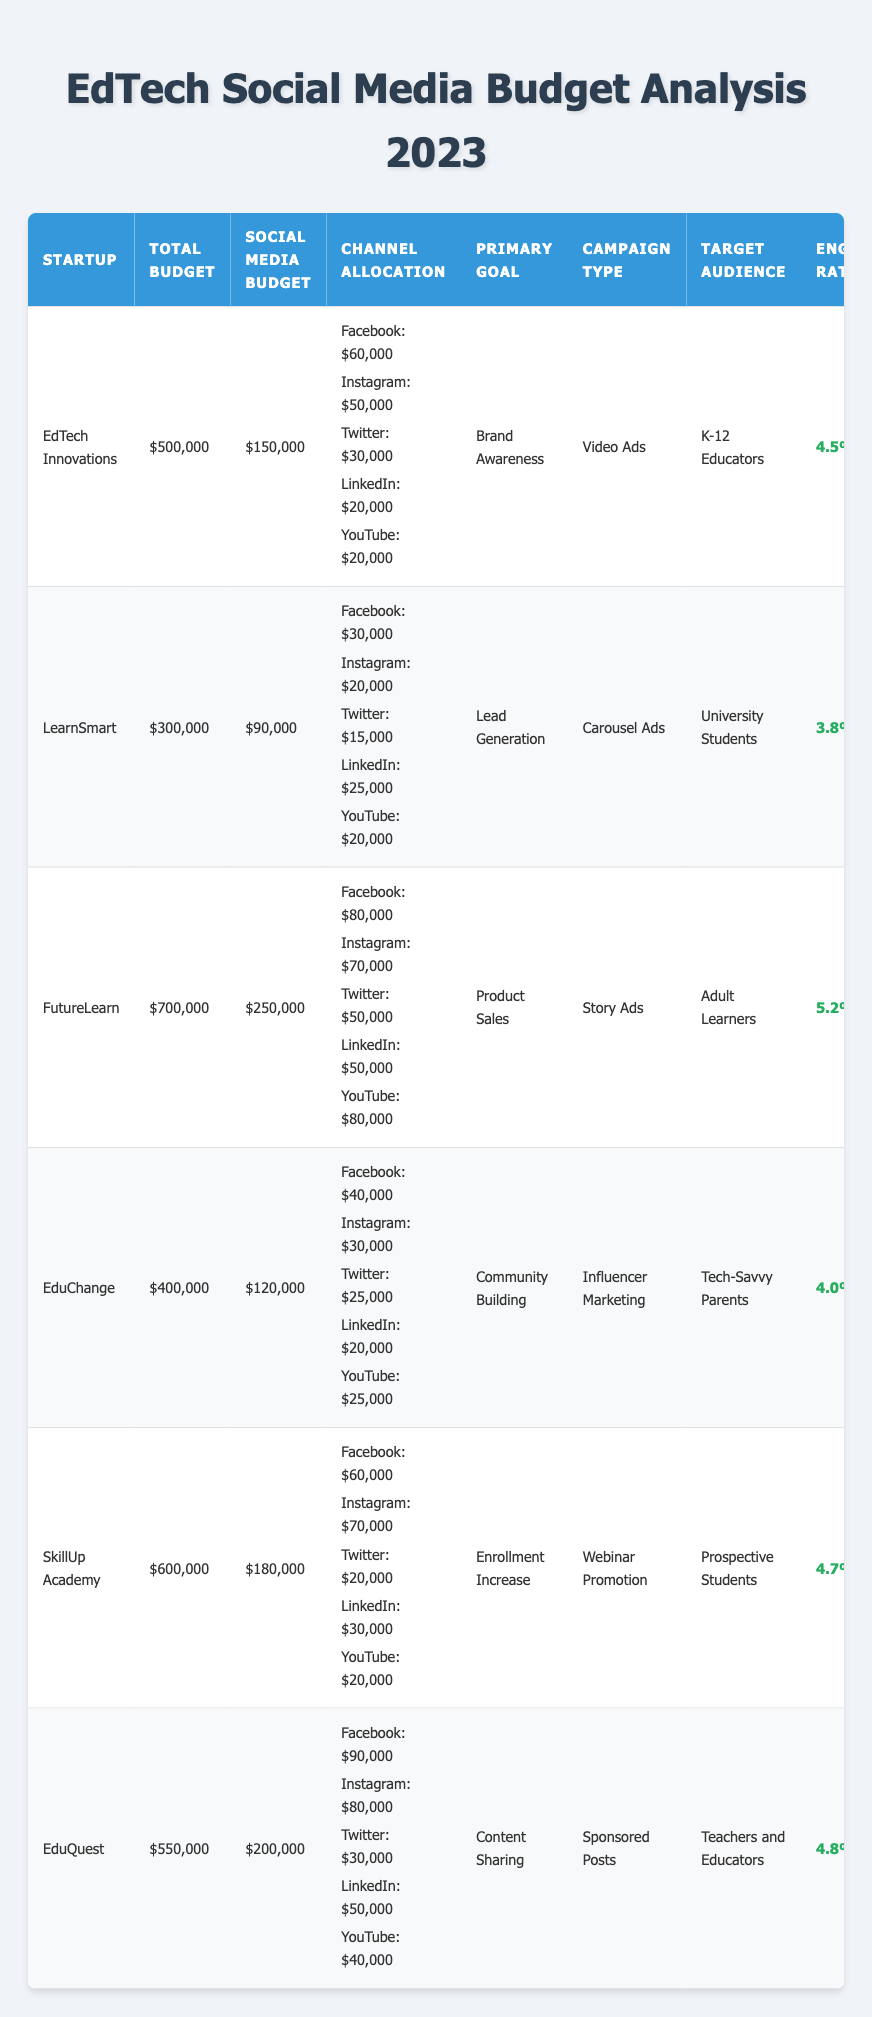What is the total budget for FutureLearn? The table shows that FutureLearn has a total budget of $700,000 listed in the column for Total Budget.
Answer: $700,000 Which startup allocated the highest amount to social media advertising? FutureLearn allocated $250,000 to social media advertising, which is the highest amount in the Social Media Budget column compared to other startups.
Answer: FutureLearn How many channels did EduChange allocate their budget towards? EduChange allocated their budget across five channels: Facebook, Instagram, Twitter, LinkedIn, and YouTube, visible in the Channel Allocation section for EduChange.
Answer: 5 What was LearnSmart's engagement rate? The engagement rate for LearnSmart is presented as 3.8% in the Engagement Rate column for that startup.
Answer: 3.8% Calculate the average social media budget allocation across all startups. To find the average, sum the social media budgets: (150,000 + 90,000 + 250,000 + 120,000 + 180,000 + 200,000) = 1,090,000. There are 6 startups, so the average is 1,090,000 / 6 = 181,666.67.
Answer: $181,667 (rounded) Did any startup use Instagram as part of their advertising strategy? Yes, all listed startups allocated a budget to Instagram, as each has a specified amount in the Channel Allocation section for Instagram.
Answer: Yes What are the primary goals of the startups with the lowest social media budgets? LearnSmart has the lowest social media budget at $90,000, and its primary goal is Lead Generation. EduChange has the second-lowest social media budget at $120,000, with a primary goal of Community Building.
Answer: LearnSmart: Lead Generation; EduChange: Community Building What is the total social media budget of SkillUp Academy and EduQuest combined? SkillUp Academy has a social media budget of $180,000 and EduQuest has $200,000; summing these gives 180,000 + 200,000 = 380,000.
Answer: $380,000 Which campaign type was used by the startup with the highest engagement rate? FutureLearn, which has the highest engagement rate of 5.2%, used Story Ads as their campaign type as noted in the Campaign Type column.
Answer: Story Ads Is the engagement rate for EdTech Innovations higher or lower than that of EduChange? EdTech Innovations has an engagement rate of 4.5%, while EduChange has an engagement rate of 4.0%. Since 4.5% is greater than 4.0%, it is higher.
Answer: Higher What percentage of the total budget did EduQuest allocate to social media advertising? EduQuest's total budget is $550,000 and they allocated $200,000 to social media, so the percentage is (200,000 / 550,000) * 100 = 36.36%.
Answer: 36.36% 